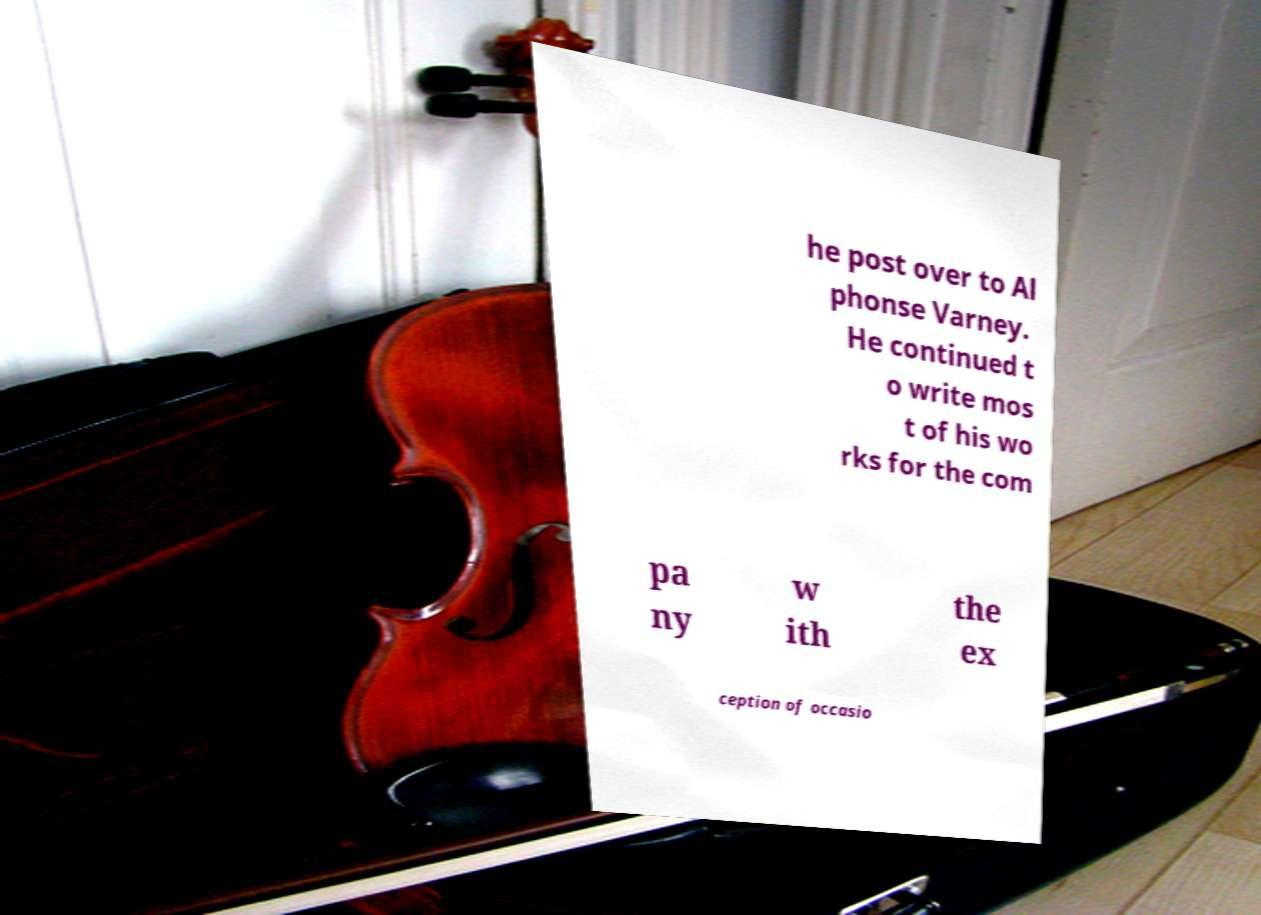There's text embedded in this image that I need extracted. Can you transcribe it verbatim? he post over to Al phonse Varney. He continued t o write mos t of his wo rks for the com pa ny w ith the ex ception of occasio 